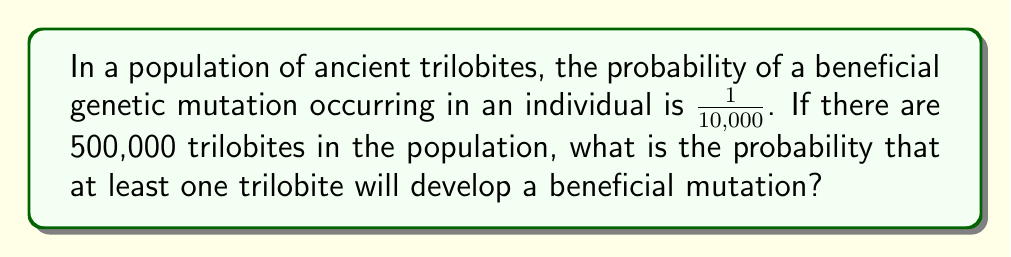Solve this math problem. Let's approach this step-by-step:

1) First, let's consider the probability of a trilobite not developing a beneficial mutation. This is:

   $P(\text{no mutation}) = 1 - \frac{1}{10,000} = \frac{9,999}{10,000}$

2) For no trilobites in the entire population to develop a mutation, this must happen independently for all 500,000 trilobites. The probability of this is:

   $P(\text{no mutations in population}) = (\frac{9,999}{10,000})^{500,000}$

3) Therefore, the probability of at least one trilobite developing a beneficial mutation is the complement of this probability:

   $P(\text{at least one mutation}) = 1 - (\frac{9,999}{10,000})^{500,000}$

4) To calculate this:
   
   $1 - (\frac{9,999}{10,000})^{500,000} = 1 - (0.9999)^{500,000}$
   
   $= 1 - e^{500,000 \ln(0.9999)}$
   
   $= 1 - e^{-50}$ (approximately)
   
   $= 1 - 1.9287 \times 10^{-22}$

5) This is extremely close to 1, indicating a very high probability.
Answer: $0.999999999999999999998$ (or $\approx 1$) 